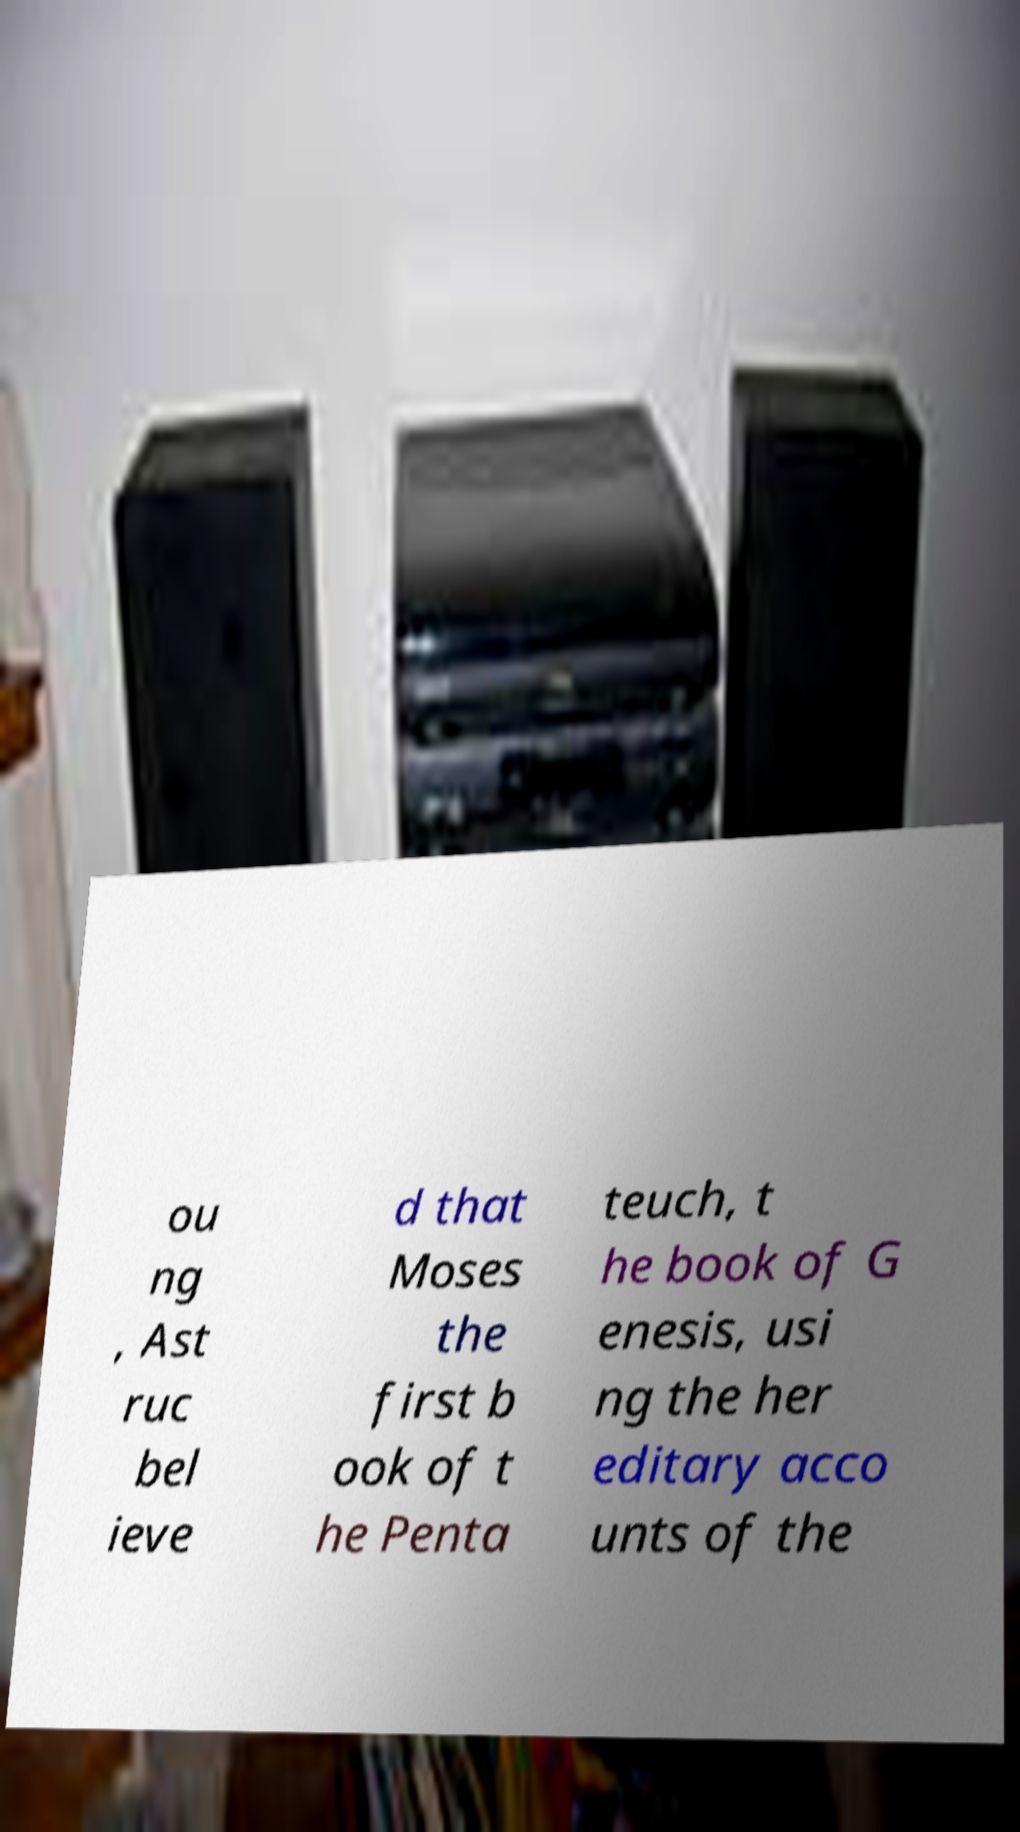For documentation purposes, I need the text within this image transcribed. Could you provide that? ou ng , Ast ruc bel ieve d that Moses the first b ook of t he Penta teuch, t he book of G enesis, usi ng the her editary acco unts of the 